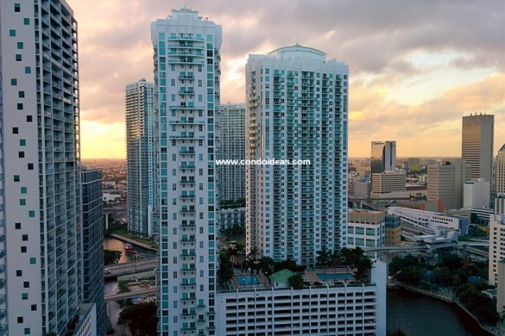Discuss the architectural style of the buildings in the image. The buildings in the image exhibit a modern architectural style, characterized by their tall, sleek, and geometrically simple designs. They feature extensive use of glass and steel, creating a reflective surface that interacts visually with the environment. The vertical lines and considerable height of the buildings speak to the efficiency of space usage in urban planning, making them iconic representations of contemporary city life. What might be happening inside these buildings at sunset? As the sun sets, employees in office spaces within the buildings might be wrapping up their workday, preparing to leave for home. Apartments could see residents winding down after a long day, potentially enjoying the sunset views from their high-rise windows. Restaurants and bars within the buildings could be gearing up for the evening rush, as people seek dinner and entertainment options. The buildings are likely a hive of various activities, reflecting the city's vibrant life even as the day ends. 